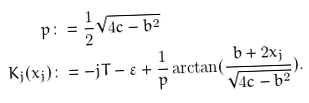<formula> <loc_0><loc_0><loc_500><loc_500>p & \colon = \frac { 1 } { 2 } \sqrt { 4 c - b ^ { 2 } } \\ K _ { j } ( x _ { j } ) & \colon = - j T - \varepsilon + \frac { 1 } { p } \arctan ( \frac { b + 2 x _ { j } } { \sqrt { 4 c - b ^ { 2 } } } ) .</formula> 